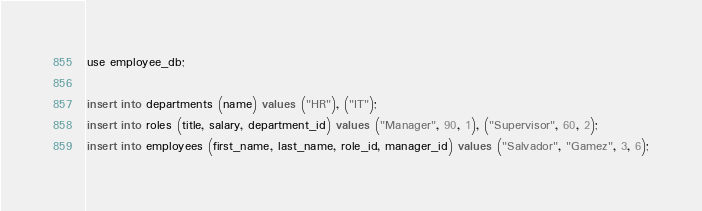<code> <loc_0><loc_0><loc_500><loc_500><_SQL_>use employee_db;

insert into departments (name) values ("HR"), ("IT");
insert into roles (title, salary, department_id) values ("Manager", 90, 1), ("Supervisor", 60, 2);
insert into employees (first_name, last_name, role_id, manager_id) values ("Salvador", "Gamez", 3, 6);</code> 